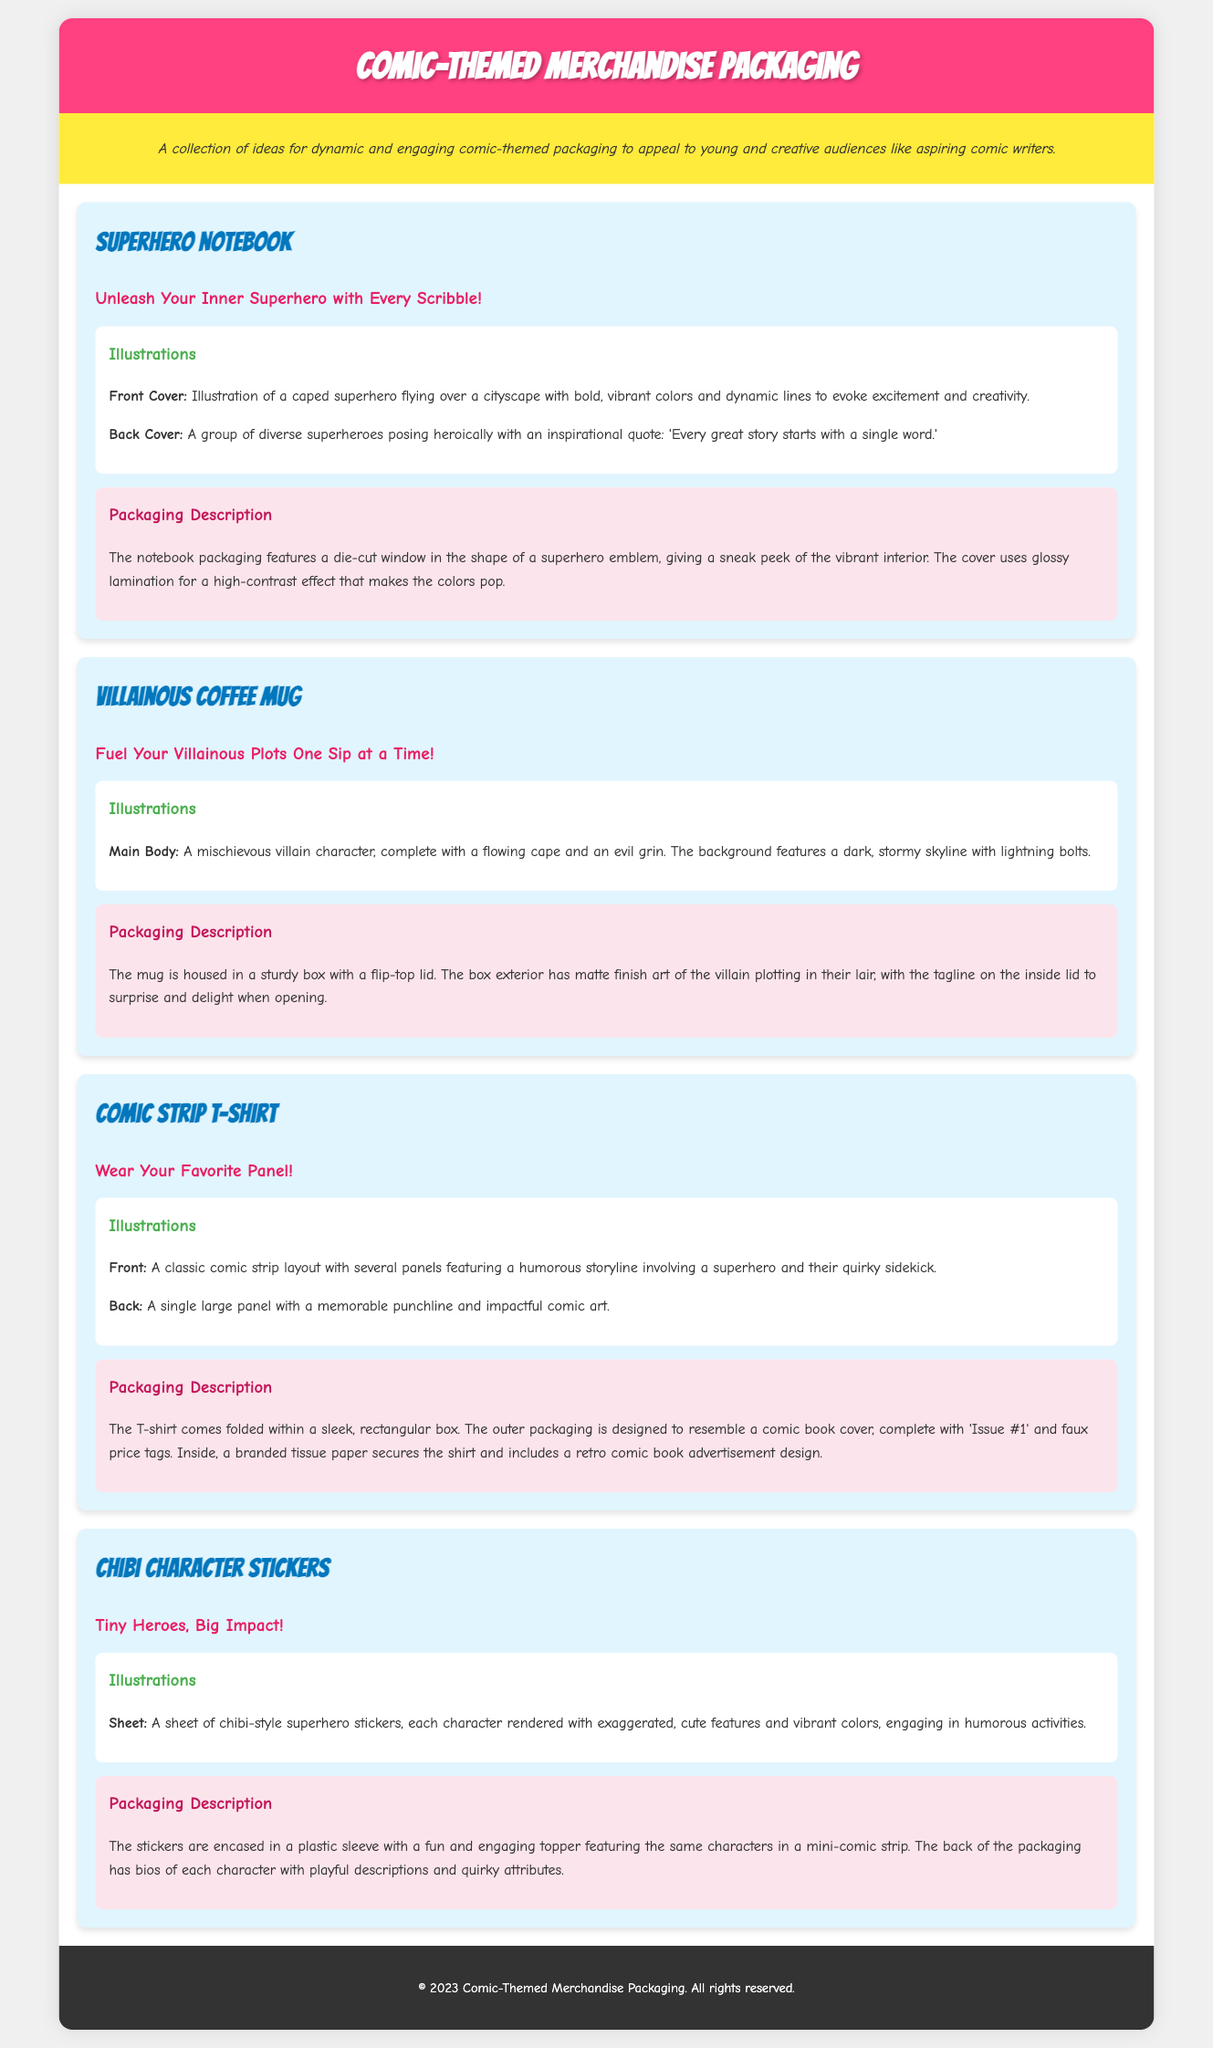What is the name of the first product? The first product listed in the document is "Superhero Notebook."
Answer: Superhero Notebook What is the tagline for the Villainous Coffee Mug? The tagline specifically associated with the Villainous Coffee Mug is "Fuel Your Villainous Plots One Sip at a Time!"
Answer: Fuel Your Villainous Plots One Sip at a Time! How many products are described in the document? The document describes four products in total, each with its own section.
Answer: Four What is featured on the back cover of the Superhero Notebook? The back cover features a group of diverse superheroes posing heroically with an inspirational quote.
Answer: Diverse superheroes with an inspirational quote What design style is used for the Chibi Character Stickers? The Chibi Character Stickers are designed in a chibi-style with exaggerated, cute features and vibrant colors.
Answer: Chibi-style What packaging feature does the Superhero Notebook have? The Superhero Notebook features a die-cut window in the shape of a superhero emblem on its packaging.
Answer: Die-cut window Which product packaging resembles a comic book cover? The T-shirt's outer packaging is designed to resemble a comic book cover.
Answer: T-shirt What is included inside the sticker packaging? The sticker packaging includes bios of each character with playful descriptions and quirky attributes.
Answer: Character bios What kind of finish does the villain's coffee mug box have? The villain's coffee mug box has a matte finish art.
Answer: Matte finish 